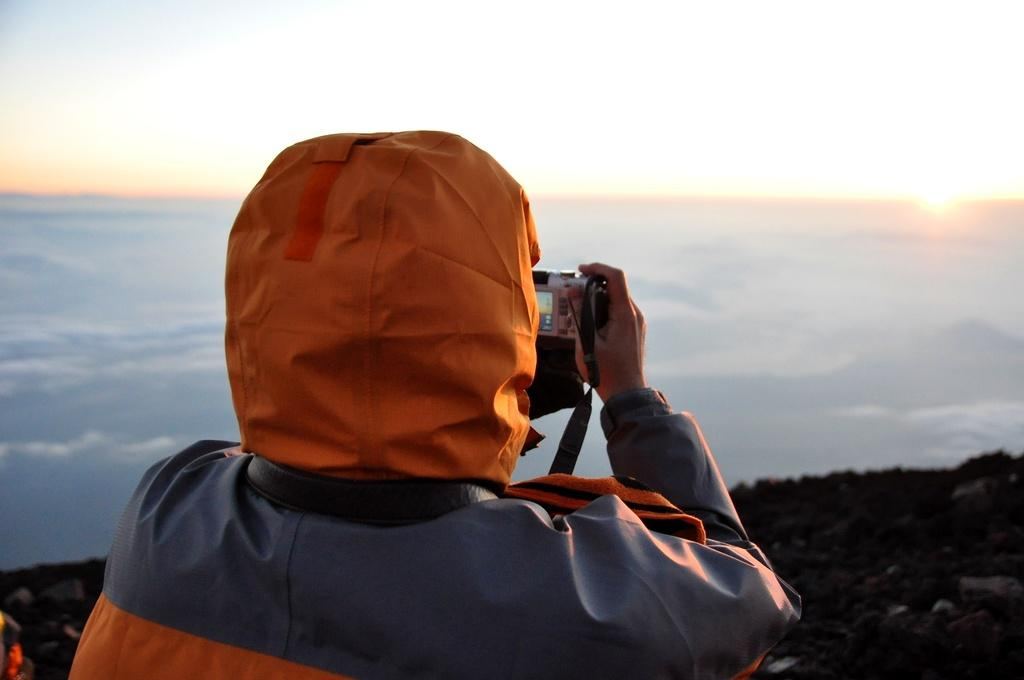What is the person in the bottom left corner of the image doing? The person is standing in the image and holding a camera. What can be seen in the background of the image? There are hills visible in the image. What is the condition of the sky in the image? The sky has clouds and the sun is visible in the image. What type of bed can be seen in the image? There is no bed present in the image. How many ducks are visible in the image? There are no ducks visible in the image. 